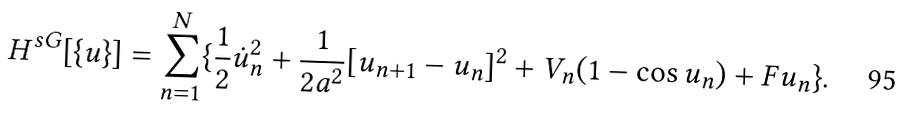Convert formula to latex. <formula><loc_0><loc_0><loc_500><loc_500>H ^ { s G } [ \{ u \} ] = \sum _ { n = 1 } ^ { N } \{ \frac { 1 } { 2 } \dot { u } _ { n } ^ { 2 } + \frac { 1 } { 2 a ^ { 2 } } [ u _ { n + 1 } - u _ { n } ] ^ { 2 } + V _ { n } ( 1 - \cos u _ { n } ) + F u _ { n } \} .</formula> 